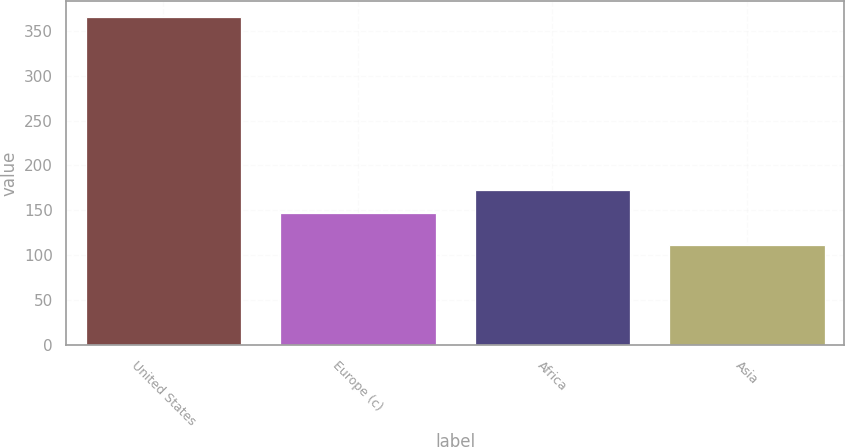<chart> <loc_0><loc_0><loc_500><loc_500><bar_chart><fcel>United States<fcel>Europe (c)<fcel>Africa<fcel>Asia<nl><fcel>365<fcel>147<fcel>172.3<fcel>112<nl></chart> 